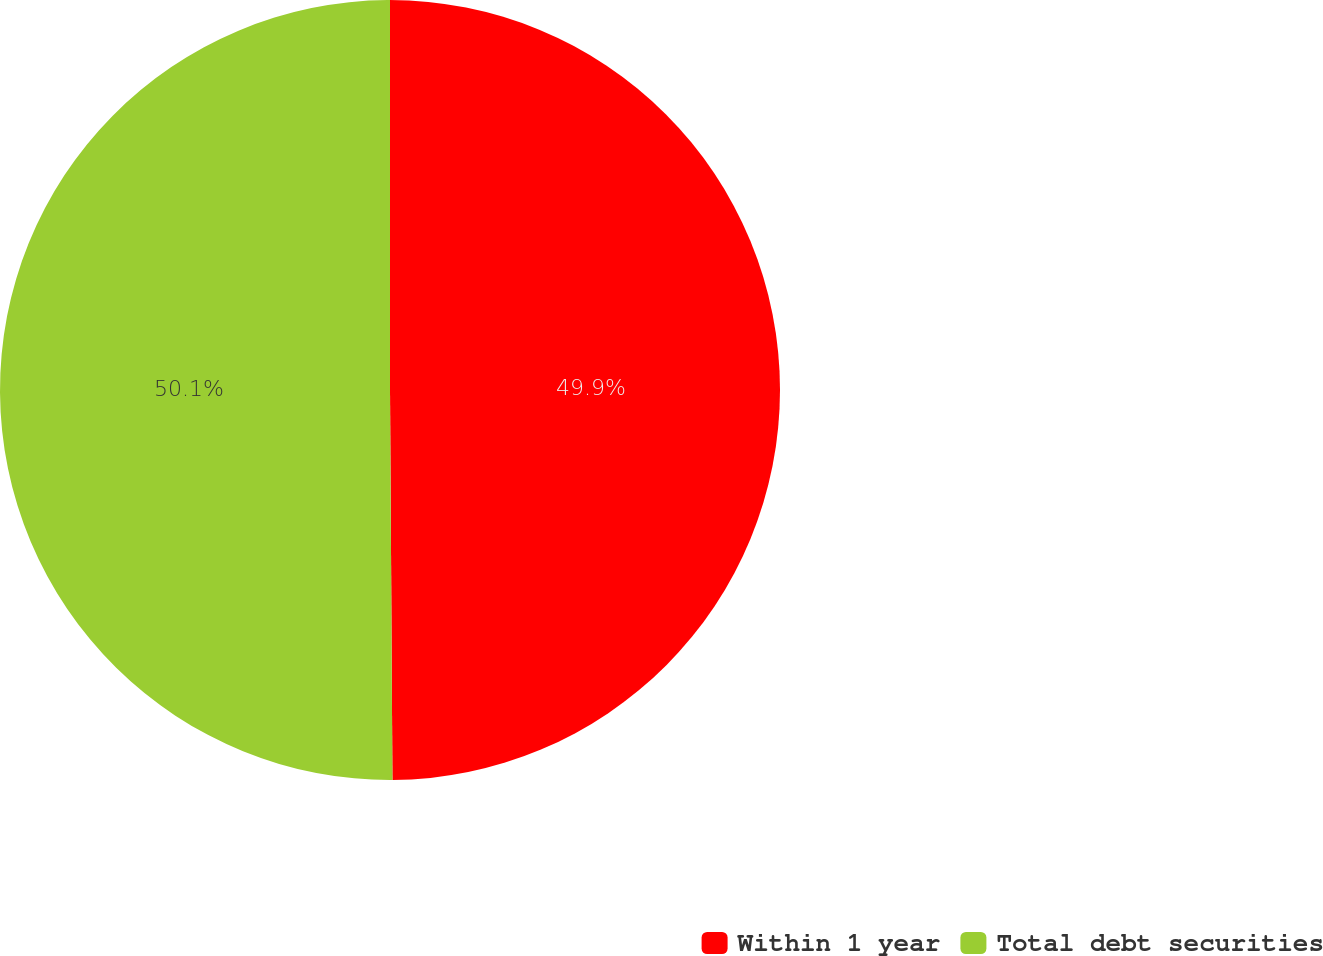<chart> <loc_0><loc_0><loc_500><loc_500><pie_chart><fcel>Within 1 year<fcel>Total debt securities<nl><fcel>49.9%<fcel>50.1%<nl></chart> 